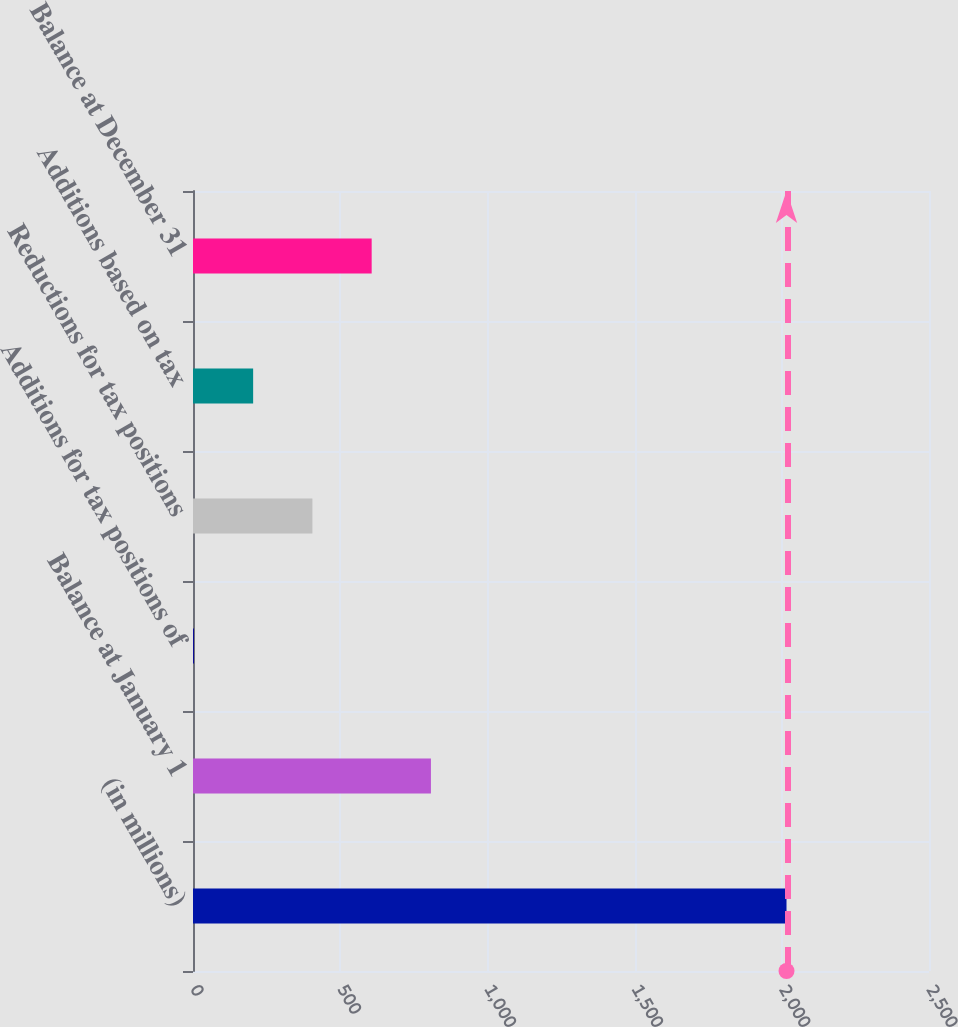<chart> <loc_0><loc_0><loc_500><loc_500><bar_chart><fcel>(in millions)<fcel>Balance at January 1<fcel>Additions for tax positions of<fcel>Reductions for tax positions<fcel>Additions based on tax<fcel>Balance at December 31<nl><fcel>2016<fcel>808.2<fcel>3<fcel>405.6<fcel>204.3<fcel>606.9<nl></chart> 